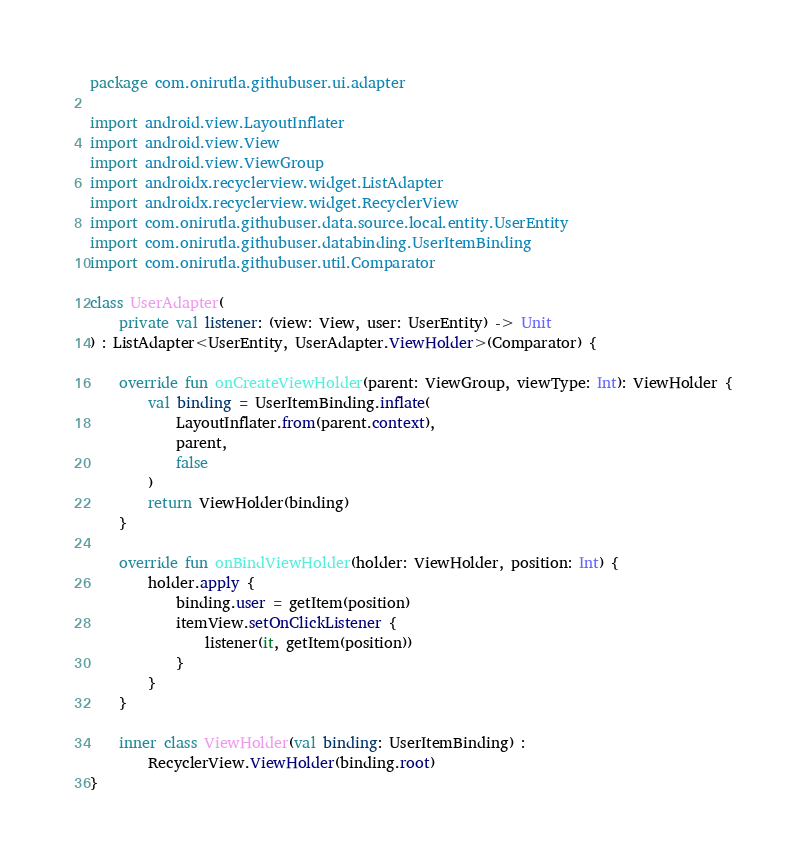<code> <loc_0><loc_0><loc_500><loc_500><_Kotlin_>package com.onirutla.githubuser.ui.adapter

import android.view.LayoutInflater
import android.view.View
import android.view.ViewGroup
import androidx.recyclerview.widget.ListAdapter
import androidx.recyclerview.widget.RecyclerView
import com.onirutla.githubuser.data.source.local.entity.UserEntity
import com.onirutla.githubuser.databinding.UserItemBinding
import com.onirutla.githubuser.util.Comparator

class UserAdapter(
    private val listener: (view: View, user: UserEntity) -> Unit
) : ListAdapter<UserEntity, UserAdapter.ViewHolder>(Comparator) {

    override fun onCreateViewHolder(parent: ViewGroup, viewType: Int): ViewHolder {
        val binding = UserItemBinding.inflate(
            LayoutInflater.from(parent.context),
            parent,
            false
        )
        return ViewHolder(binding)
    }

    override fun onBindViewHolder(holder: ViewHolder, position: Int) {
        holder.apply {
            binding.user = getItem(position)
            itemView.setOnClickListener {
                listener(it, getItem(position))
            }
        }
    }

    inner class ViewHolder(val binding: UserItemBinding) :
        RecyclerView.ViewHolder(binding.root)
}</code> 